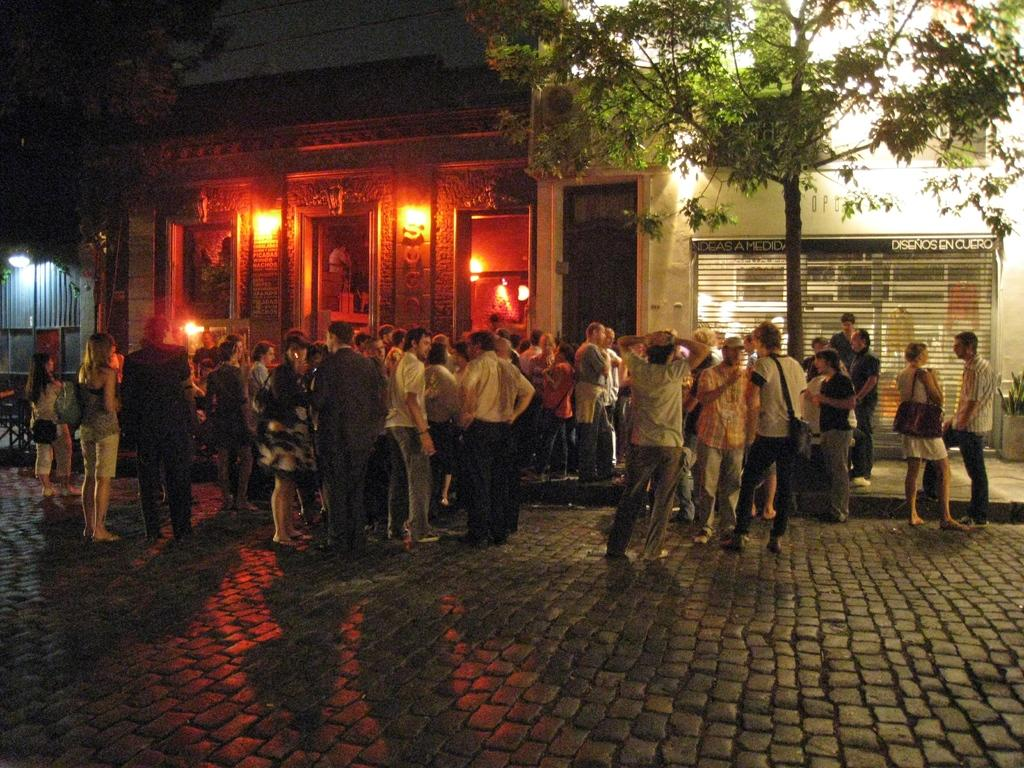What can be seen in the image involving people? There are people standing in the image. What type of structures are present in the image? There are buildings in the image. What architectural features can be observed on the buildings? There are doors in the image. What type of illumination is present in the image? There are lights on the wall in the image. What natural elements are visible in the image? There are trees and plants in the image. Can you describe any other objects in the image? There are unspecified objects in the image. What disease is being treated by the fireman in the image? There is no fireman or disease present in the image. How many pages are visible in the image? There are no pages present in the image. 